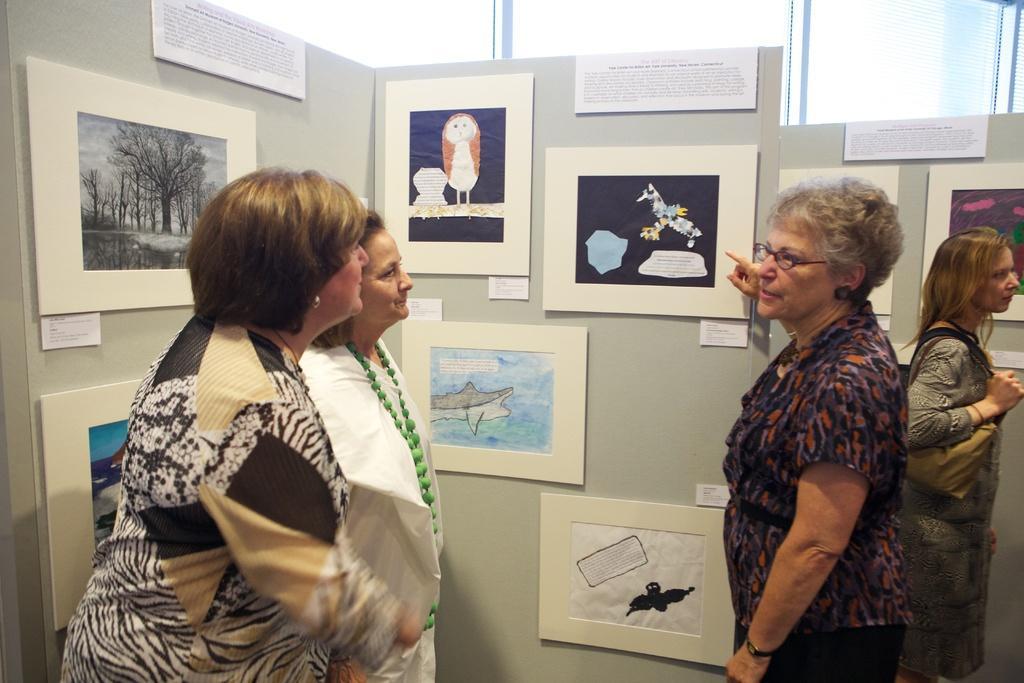Can you describe this image briefly? In this image, there are a few people. We can see the walls with some posters and boards with text and images. We can see some glass. 